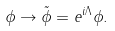Convert formula to latex. <formula><loc_0><loc_0><loc_500><loc_500>\phi \rightarrow \tilde { \phi } = e ^ { i \Lambda } \phi .</formula> 